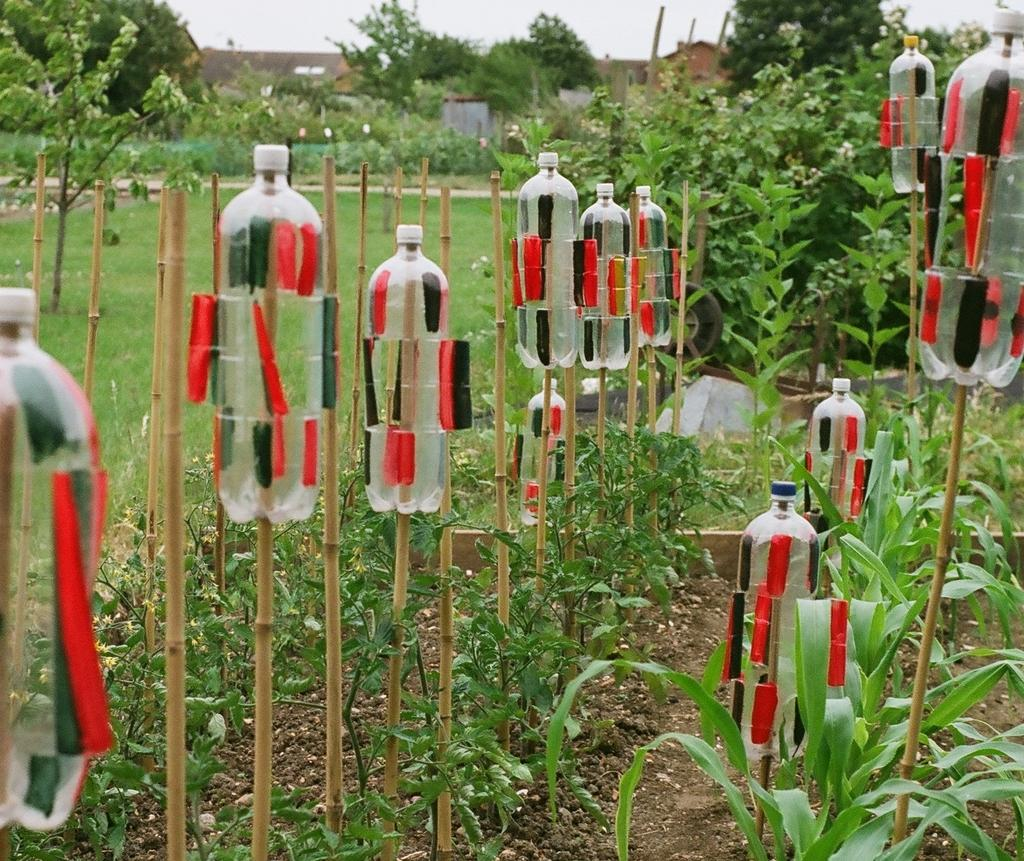What can be seen in the image that consists of multiple trunks and branches? There is a group of trees in the image. What is attached to one of the trees in the image? A stick and a bottle are attached to one of the trees in the image. What can be seen in the background of the image? There are trees and buildings in the background of the image. What is the ground covered with in the image? The ground is covered in greenery. What type of metal is used to construct the hospital in the image? There is no hospital present in the image; it features a group of trees with a stick and bottle attached to one of them, along with trees and buildings in the background. 